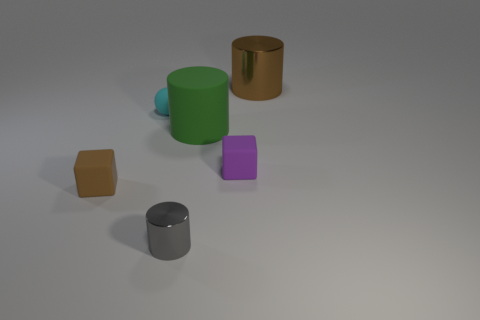Add 4 big purple blocks. How many objects exist? 10 Subtract all gray metal cylinders. How many cylinders are left? 2 Subtract 3 cylinders. How many cylinders are left? 0 Subtract all gray cylinders. How many cylinders are left? 2 Subtract all spheres. How many objects are left? 5 Subtract all purple cylinders. Subtract all gray balls. How many cylinders are left? 3 Subtract all brown blocks. How many green cylinders are left? 1 Subtract all green rubber objects. Subtract all balls. How many objects are left? 4 Add 6 metallic objects. How many metallic objects are left? 8 Add 5 small matte spheres. How many small matte spheres exist? 6 